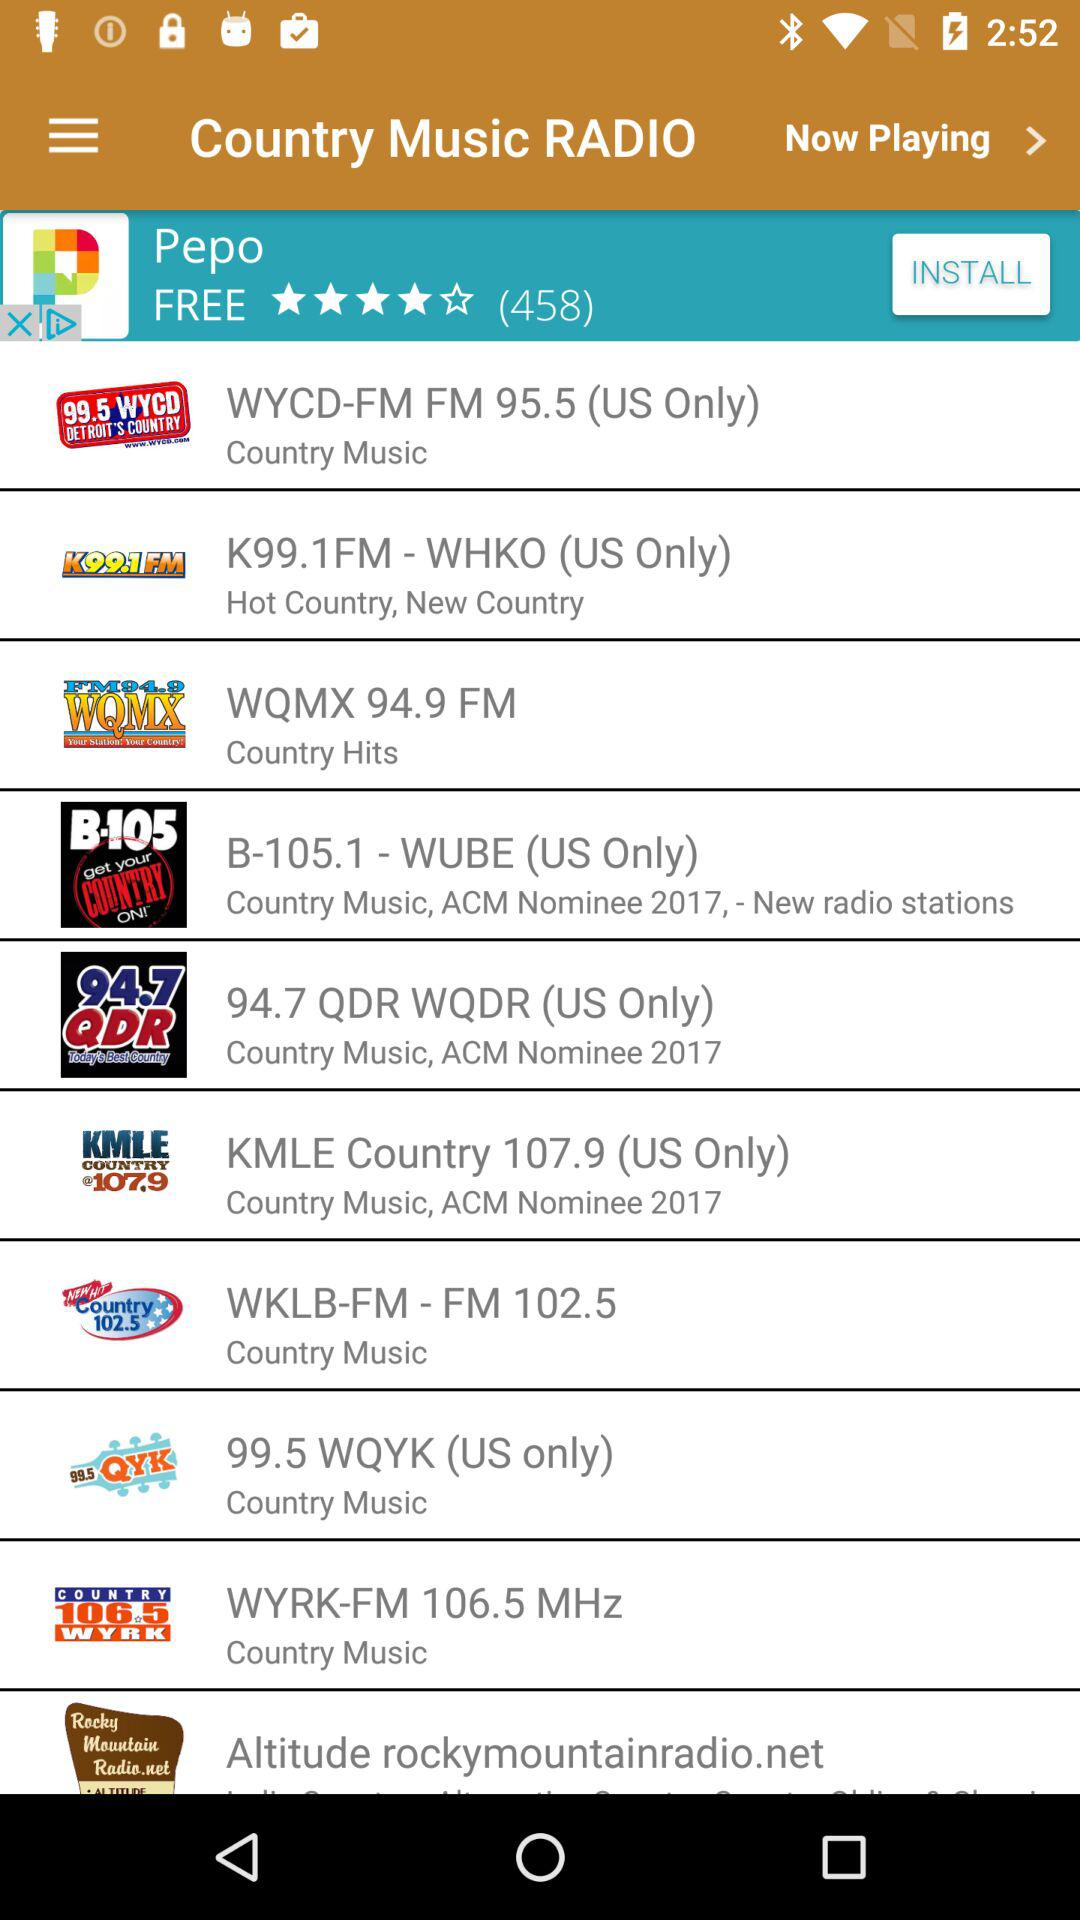What radio stations play only in the US? The radio stations playing only in the US are: "WYCD-FM FM 95.5", "K99.1FM - WHKO", "B-105.1 - WUBE", "94.7 QDR WQDR", "KMLE Country 107.9" and "KMLE Country 107.9". 